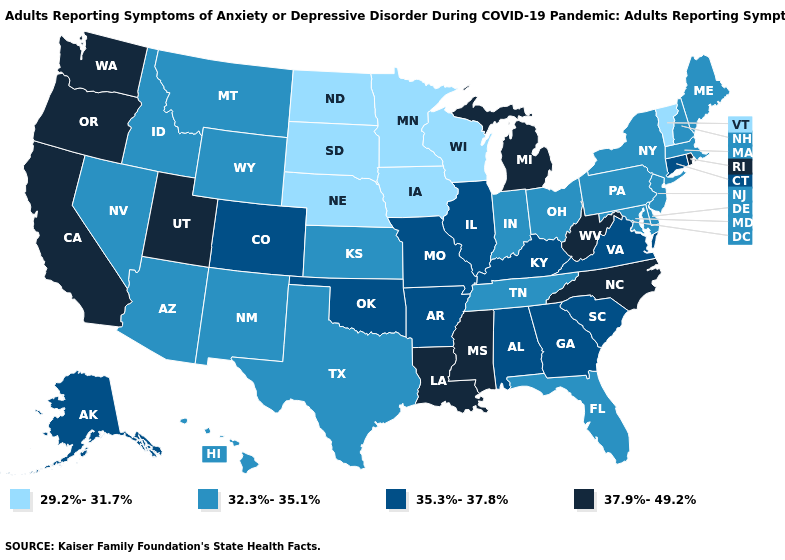Among the states that border Kentucky , which have the lowest value?
Give a very brief answer. Indiana, Ohio, Tennessee. What is the value of Wyoming?
Concise answer only. 32.3%-35.1%. What is the lowest value in the USA?
Answer briefly. 29.2%-31.7%. Does Nevada have a higher value than Nebraska?
Concise answer only. Yes. Name the states that have a value in the range 37.9%-49.2%?
Answer briefly. California, Louisiana, Michigan, Mississippi, North Carolina, Oregon, Rhode Island, Utah, Washington, West Virginia. Name the states that have a value in the range 32.3%-35.1%?
Short answer required. Arizona, Delaware, Florida, Hawaii, Idaho, Indiana, Kansas, Maine, Maryland, Massachusetts, Montana, Nevada, New Hampshire, New Jersey, New Mexico, New York, Ohio, Pennsylvania, Tennessee, Texas, Wyoming. Does Georgia have a lower value than Washington?
Concise answer only. Yes. What is the value of Oklahoma?
Be succinct. 35.3%-37.8%. Which states hav the highest value in the MidWest?
Give a very brief answer. Michigan. Name the states that have a value in the range 32.3%-35.1%?
Answer briefly. Arizona, Delaware, Florida, Hawaii, Idaho, Indiana, Kansas, Maine, Maryland, Massachusetts, Montana, Nevada, New Hampshire, New Jersey, New Mexico, New York, Ohio, Pennsylvania, Tennessee, Texas, Wyoming. Does the first symbol in the legend represent the smallest category?
Answer briefly. Yes. Name the states that have a value in the range 35.3%-37.8%?
Give a very brief answer. Alabama, Alaska, Arkansas, Colorado, Connecticut, Georgia, Illinois, Kentucky, Missouri, Oklahoma, South Carolina, Virginia. Among the states that border Colorado , which have the lowest value?
Quick response, please. Nebraska. What is the lowest value in the South?
Be succinct. 32.3%-35.1%. How many symbols are there in the legend?
Concise answer only. 4. 